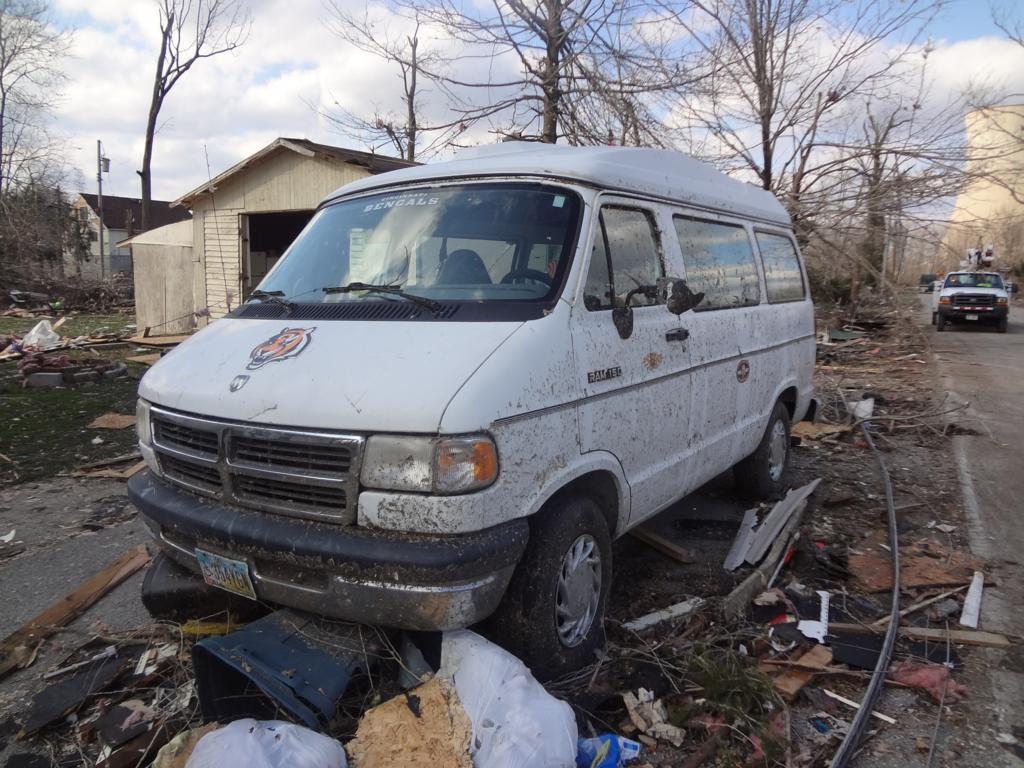What is the main subject in the foreground of the image? There is a white van in the foreground of the image. What can be seen beside the road in the image? Garbage is present beside the road. What type of natural elements are visible in the background of the image? There are trees in the background of the image. What type of structures can be seen in the background of the image? There are houses and poles in the background of the image. What is visible in the sky in the image? The sky is visible in the background of the image, and there are clouds present. Where is the nest of the bird located in the image? There is no nest of a bird present in the image. How many clocks can be seen hanging on the poles in the image? There are no clocks visible on the poles in the image. 